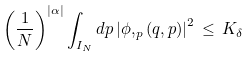Convert formula to latex. <formula><loc_0><loc_0><loc_500><loc_500>\left ( \frac { 1 } { N } \right ) ^ { | \alpha | } \int _ { I _ { N } } d p \left | \phi , _ { p } \left ( q , p \right ) \right | ^ { 2 } \, \leq \, K _ { \delta }</formula> 